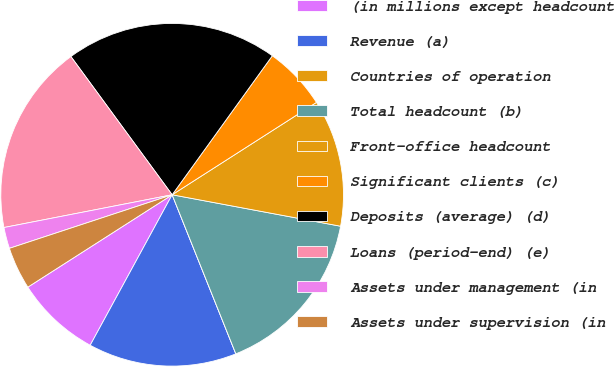Convert chart to OTSL. <chart><loc_0><loc_0><loc_500><loc_500><pie_chart><fcel>(in millions except headcount<fcel>Revenue (a)<fcel>Countries of operation<fcel>Total headcount (b)<fcel>Front-office headcount<fcel>Significant clients (c)<fcel>Deposits (average) (d)<fcel>Loans (period-end) (e)<fcel>Assets under management (in<fcel>Assets under supervision (in<nl><fcel>8.0%<fcel>14.0%<fcel>0.0%<fcel>16.0%<fcel>12.0%<fcel>6.0%<fcel>20.0%<fcel>18.0%<fcel>2.0%<fcel>4.0%<nl></chart> 